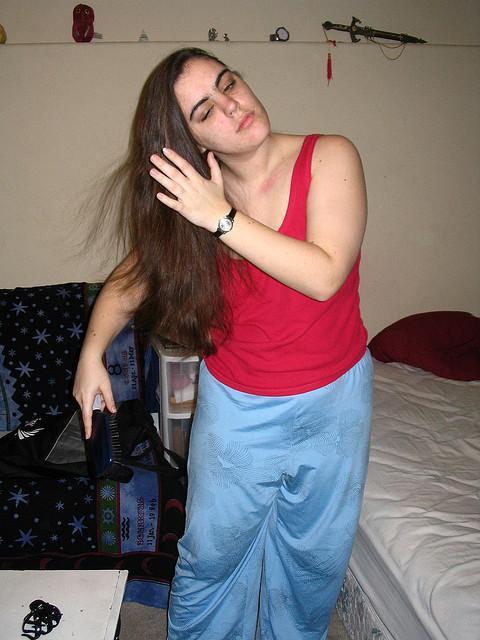Does the image validate the caption "The person is out of the couch."?
Answer yes or no. Yes. 